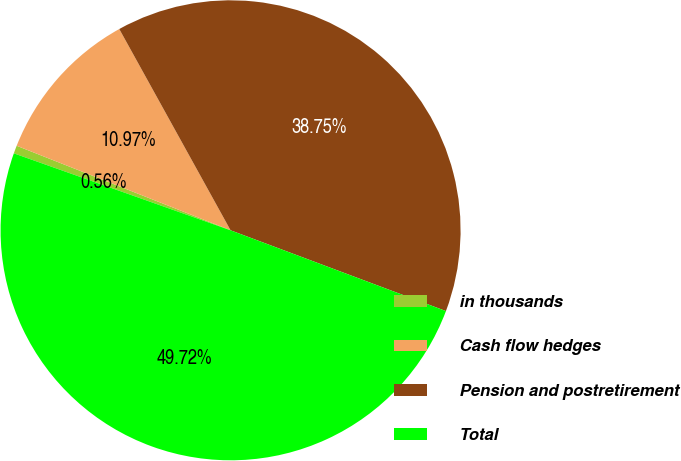Convert chart. <chart><loc_0><loc_0><loc_500><loc_500><pie_chart><fcel>in thousands<fcel>Cash flow hedges<fcel>Pension and postretirement<fcel>Total<nl><fcel>0.56%<fcel>10.97%<fcel>38.75%<fcel>49.72%<nl></chart> 